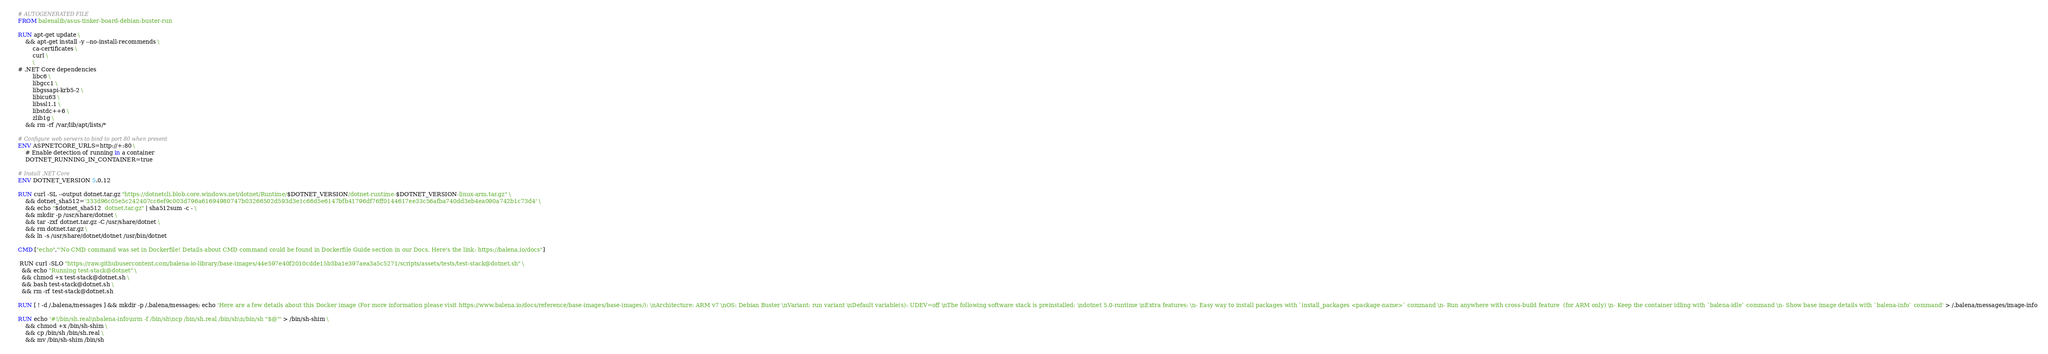Convert code to text. <code><loc_0><loc_0><loc_500><loc_500><_Dockerfile_># AUTOGENERATED FILE
FROM balenalib/asus-tinker-board-debian:buster-run

RUN apt-get update \
    && apt-get install -y --no-install-recommends \
        ca-certificates \
        curl \
        \
# .NET Core dependencies
        libc6 \
        libgcc1 \
        libgssapi-krb5-2 \
        libicu63 \
        libssl1.1 \
        libstdc++6 \
        zlib1g \
    && rm -rf /var/lib/apt/lists/*

# Configure web servers to bind to port 80 when present
ENV ASPNETCORE_URLS=http://+:80 \
    # Enable detection of running in a container
    DOTNET_RUNNING_IN_CONTAINER=true

# Install .NET Core
ENV DOTNET_VERSION 5.0.12

RUN curl -SL --output dotnet.tar.gz "https://dotnetcli.blob.core.windows.net/dotnet/Runtime/$DOTNET_VERSION/dotnet-runtime-$DOTNET_VERSION-linux-arm.tar.gz" \
    && dotnet_sha512='333d96c05e5c242407cc6ef9c003d796a61694980747b03266502d593d3e1c66d5e6147bfb41796df76ff0144617ee33c56afba740dd3eb4ea090a742b1c73d4' \
    && echo "$dotnet_sha512  dotnet.tar.gz" | sha512sum -c - \
    && mkdir -p /usr/share/dotnet \
    && tar -zxf dotnet.tar.gz -C /usr/share/dotnet \
    && rm dotnet.tar.gz \
    && ln -s /usr/share/dotnet/dotnet /usr/bin/dotnet

CMD ["echo","'No CMD command was set in Dockerfile! Details about CMD command could be found in Dockerfile Guide section in our Docs. Here's the link: https://balena.io/docs"]

 RUN curl -SLO "https://raw.githubusercontent.com/balena-io-library/base-images/44e597e40f2010cdde15b3ba1e397aea3a5c5271/scripts/assets/tests/test-stack@dotnet.sh" \
  && echo "Running test-stack@dotnet" \
  && chmod +x test-stack@dotnet.sh \
  && bash test-stack@dotnet.sh \
  && rm -rf test-stack@dotnet.sh 

RUN [ ! -d /.balena/messages ] && mkdir -p /.balena/messages; echo 'Here are a few details about this Docker image (For more information please visit https://www.balena.io/docs/reference/base-images/base-images/): \nArchitecture: ARM v7 \nOS: Debian Buster \nVariant: run variant \nDefault variable(s): UDEV=off \nThe following software stack is preinstalled: \ndotnet 5.0-runtime \nExtra features: \n- Easy way to install packages with `install_packages <package-name>` command \n- Run anywhere with cross-build feature  (for ARM only) \n- Keep the container idling with `balena-idle` command \n- Show base image details with `balena-info` command' > /.balena/messages/image-info

RUN echo '#!/bin/sh.real\nbalena-info\nrm -f /bin/sh\ncp /bin/sh.real /bin/sh\n/bin/sh "$@"' > /bin/sh-shim \
	&& chmod +x /bin/sh-shim \
	&& cp /bin/sh /bin/sh.real \
	&& mv /bin/sh-shim /bin/sh</code> 